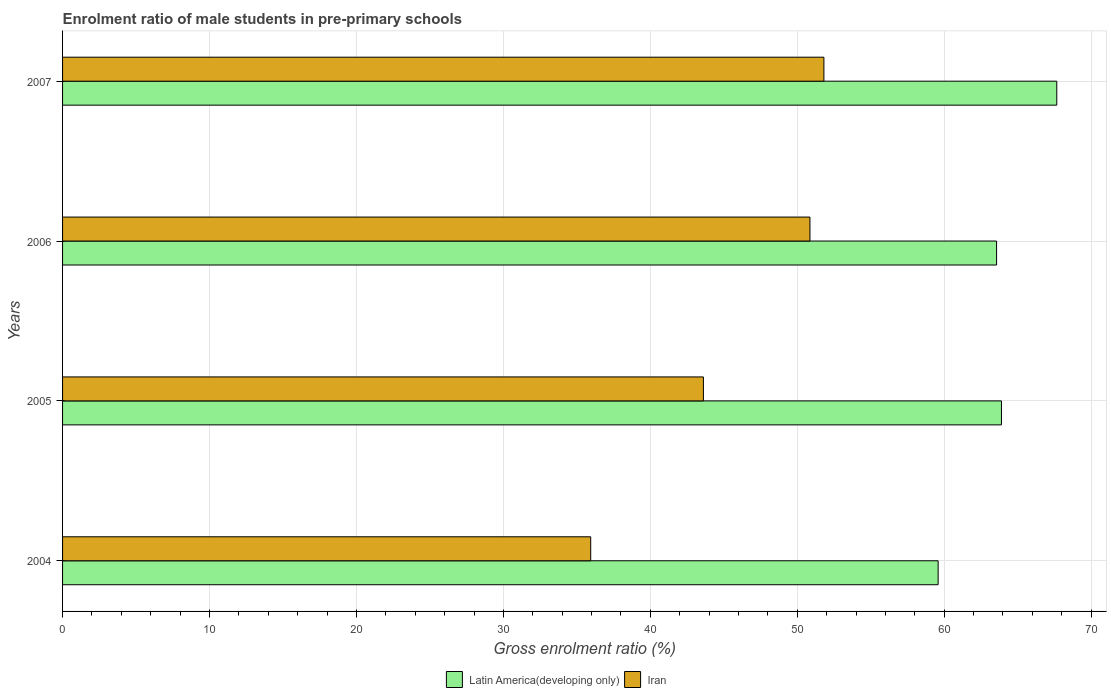Are the number of bars on each tick of the Y-axis equal?
Provide a succinct answer. Yes. How many bars are there on the 3rd tick from the top?
Make the answer very short. 2. How many bars are there on the 1st tick from the bottom?
Make the answer very short. 2. What is the label of the 1st group of bars from the top?
Your answer should be compact. 2007. In how many cases, is the number of bars for a given year not equal to the number of legend labels?
Your answer should be very brief. 0. What is the enrolment ratio of male students in pre-primary schools in Iran in 2007?
Offer a very short reply. 51.81. Across all years, what is the maximum enrolment ratio of male students in pre-primary schools in Iran?
Give a very brief answer. 51.81. Across all years, what is the minimum enrolment ratio of male students in pre-primary schools in Latin America(developing only)?
Provide a succinct answer. 59.59. In which year was the enrolment ratio of male students in pre-primary schools in Latin America(developing only) minimum?
Your response must be concise. 2004. What is the total enrolment ratio of male students in pre-primary schools in Iran in the graph?
Offer a very short reply. 182.23. What is the difference between the enrolment ratio of male students in pre-primary schools in Latin America(developing only) in 2005 and that in 2006?
Keep it short and to the point. 0.33. What is the difference between the enrolment ratio of male students in pre-primary schools in Iran in 2006 and the enrolment ratio of male students in pre-primary schools in Latin America(developing only) in 2007?
Make the answer very short. -16.8. What is the average enrolment ratio of male students in pre-primary schools in Latin America(developing only) per year?
Keep it short and to the point. 63.68. In the year 2004, what is the difference between the enrolment ratio of male students in pre-primary schools in Iran and enrolment ratio of male students in pre-primary schools in Latin America(developing only)?
Make the answer very short. -23.64. In how many years, is the enrolment ratio of male students in pre-primary schools in Iran greater than 20 %?
Provide a succinct answer. 4. What is the ratio of the enrolment ratio of male students in pre-primary schools in Iran in 2005 to that in 2007?
Ensure brevity in your answer.  0.84. Is the difference between the enrolment ratio of male students in pre-primary schools in Iran in 2004 and 2007 greater than the difference between the enrolment ratio of male students in pre-primary schools in Latin America(developing only) in 2004 and 2007?
Give a very brief answer. No. What is the difference between the highest and the second highest enrolment ratio of male students in pre-primary schools in Iran?
Offer a terse response. 0.95. What is the difference between the highest and the lowest enrolment ratio of male students in pre-primary schools in Iran?
Your answer should be compact. 15.87. What does the 2nd bar from the top in 2006 represents?
Your answer should be compact. Latin America(developing only). What does the 1st bar from the bottom in 2006 represents?
Your response must be concise. Latin America(developing only). Are all the bars in the graph horizontal?
Give a very brief answer. Yes. Does the graph contain any zero values?
Your answer should be compact. No. How many legend labels are there?
Offer a very short reply. 2. How are the legend labels stacked?
Your response must be concise. Horizontal. What is the title of the graph?
Offer a very short reply. Enrolment ratio of male students in pre-primary schools. Does "Czech Republic" appear as one of the legend labels in the graph?
Your answer should be very brief. No. What is the label or title of the X-axis?
Make the answer very short. Gross enrolment ratio (%). What is the Gross enrolment ratio (%) in Latin America(developing only) in 2004?
Give a very brief answer. 59.59. What is the Gross enrolment ratio (%) in Iran in 2004?
Offer a very short reply. 35.94. What is the Gross enrolment ratio (%) in Latin America(developing only) in 2005?
Your answer should be compact. 63.9. What is the Gross enrolment ratio (%) of Iran in 2005?
Offer a very short reply. 43.61. What is the Gross enrolment ratio (%) of Latin America(developing only) in 2006?
Offer a very short reply. 63.56. What is the Gross enrolment ratio (%) in Iran in 2006?
Your answer should be compact. 50.86. What is the Gross enrolment ratio (%) in Latin America(developing only) in 2007?
Your answer should be compact. 67.66. What is the Gross enrolment ratio (%) of Iran in 2007?
Keep it short and to the point. 51.81. Across all years, what is the maximum Gross enrolment ratio (%) in Latin America(developing only)?
Provide a succinct answer. 67.66. Across all years, what is the maximum Gross enrolment ratio (%) of Iran?
Provide a short and direct response. 51.81. Across all years, what is the minimum Gross enrolment ratio (%) in Latin America(developing only)?
Give a very brief answer. 59.59. Across all years, what is the minimum Gross enrolment ratio (%) in Iran?
Provide a succinct answer. 35.94. What is the total Gross enrolment ratio (%) in Latin America(developing only) in the graph?
Offer a terse response. 254.71. What is the total Gross enrolment ratio (%) of Iran in the graph?
Ensure brevity in your answer.  182.23. What is the difference between the Gross enrolment ratio (%) in Latin America(developing only) in 2004 and that in 2005?
Provide a short and direct response. -4.31. What is the difference between the Gross enrolment ratio (%) of Iran in 2004 and that in 2005?
Offer a terse response. -7.67. What is the difference between the Gross enrolment ratio (%) of Latin America(developing only) in 2004 and that in 2006?
Provide a succinct answer. -3.98. What is the difference between the Gross enrolment ratio (%) of Iran in 2004 and that in 2006?
Provide a succinct answer. -14.92. What is the difference between the Gross enrolment ratio (%) in Latin America(developing only) in 2004 and that in 2007?
Your response must be concise. -8.07. What is the difference between the Gross enrolment ratio (%) of Iran in 2004 and that in 2007?
Your response must be concise. -15.87. What is the difference between the Gross enrolment ratio (%) of Latin America(developing only) in 2005 and that in 2006?
Your response must be concise. 0.33. What is the difference between the Gross enrolment ratio (%) in Iran in 2005 and that in 2006?
Give a very brief answer. -7.25. What is the difference between the Gross enrolment ratio (%) of Latin America(developing only) in 2005 and that in 2007?
Offer a terse response. -3.77. What is the difference between the Gross enrolment ratio (%) in Iran in 2005 and that in 2007?
Give a very brief answer. -8.2. What is the difference between the Gross enrolment ratio (%) in Latin America(developing only) in 2006 and that in 2007?
Offer a very short reply. -4.1. What is the difference between the Gross enrolment ratio (%) of Iran in 2006 and that in 2007?
Give a very brief answer. -0.95. What is the difference between the Gross enrolment ratio (%) in Latin America(developing only) in 2004 and the Gross enrolment ratio (%) in Iran in 2005?
Your response must be concise. 15.97. What is the difference between the Gross enrolment ratio (%) in Latin America(developing only) in 2004 and the Gross enrolment ratio (%) in Iran in 2006?
Make the answer very short. 8.72. What is the difference between the Gross enrolment ratio (%) of Latin America(developing only) in 2004 and the Gross enrolment ratio (%) of Iran in 2007?
Ensure brevity in your answer.  7.77. What is the difference between the Gross enrolment ratio (%) of Latin America(developing only) in 2005 and the Gross enrolment ratio (%) of Iran in 2006?
Your response must be concise. 13.03. What is the difference between the Gross enrolment ratio (%) of Latin America(developing only) in 2005 and the Gross enrolment ratio (%) of Iran in 2007?
Offer a very short reply. 12.08. What is the difference between the Gross enrolment ratio (%) of Latin America(developing only) in 2006 and the Gross enrolment ratio (%) of Iran in 2007?
Give a very brief answer. 11.75. What is the average Gross enrolment ratio (%) of Latin America(developing only) per year?
Make the answer very short. 63.68. What is the average Gross enrolment ratio (%) in Iran per year?
Offer a very short reply. 45.56. In the year 2004, what is the difference between the Gross enrolment ratio (%) of Latin America(developing only) and Gross enrolment ratio (%) of Iran?
Provide a short and direct response. 23.64. In the year 2005, what is the difference between the Gross enrolment ratio (%) in Latin America(developing only) and Gross enrolment ratio (%) in Iran?
Your response must be concise. 20.28. In the year 2006, what is the difference between the Gross enrolment ratio (%) of Latin America(developing only) and Gross enrolment ratio (%) of Iran?
Your answer should be compact. 12.7. In the year 2007, what is the difference between the Gross enrolment ratio (%) of Latin America(developing only) and Gross enrolment ratio (%) of Iran?
Make the answer very short. 15.85. What is the ratio of the Gross enrolment ratio (%) in Latin America(developing only) in 2004 to that in 2005?
Your response must be concise. 0.93. What is the ratio of the Gross enrolment ratio (%) of Iran in 2004 to that in 2005?
Keep it short and to the point. 0.82. What is the ratio of the Gross enrolment ratio (%) of Latin America(developing only) in 2004 to that in 2006?
Give a very brief answer. 0.94. What is the ratio of the Gross enrolment ratio (%) in Iran in 2004 to that in 2006?
Your response must be concise. 0.71. What is the ratio of the Gross enrolment ratio (%) in Latin America(developing only) in 2004 to that in 2007?
Provide a succinct answer. 0.88. What is the ratio of the Gross enrolment ratio (%) of Iran in 2004 to that in 2007?
Your response must be concise. 0.69. What is the ratio of the Gross enrolment ratio (%) in Iran in 2005 to that in 2006?
Provide a succinct answer. 0.86. What is the ratio of the Gross enrolment ratio (%) in Latin America(developing only) in 2005 to that in 2007?
Provide a succinct answer. 0.94. What is the ratio of the Gross enrolment ratio (%) in Iran in 2005 to that in 2007?
Ensure brevity in your answer.  0.84. What is the ratio of the Gross enrolment ratio (%) in Latin America(developing only) in 2006 to that in 2007?
Your answer should be compact. 0.94. What is the ratio of the Gross enrolment ratio (%) in Iran in 2006 to that in 2007?
Provide a succinct answer. 0.98. What is the difference between the highest and the second highest Gross enrolment ratio (%) of Latin America(developing only)?
Provide a succinct answer. 3.77. What is the difference between the highest and the second highest Gross enrolment ratio (%) in Iran?
Give a very brief answer. 0.95. What is the difference between the highest and the lowest Gross enrolment ratio (%) of Latin America(developing only)?
Ensure brevity in your answer.  8.07. What is the difference between the highest and the lowest Gross enrolment ratio (%) of Iran?
Your response must be concise. 15.87. 